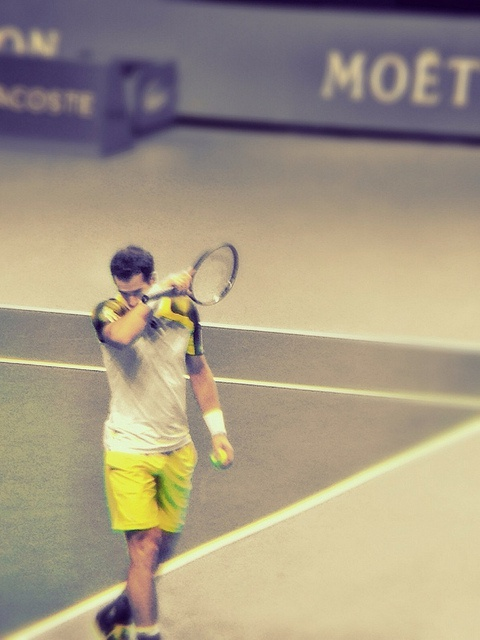Describe the objects in this image and their specific colors. I can see people in purple, khaki, gray, and tan tones, tennis racket in purple, tan, and gray tones, and sports ball in purple, khaki, olive, and tan tones in this image. 